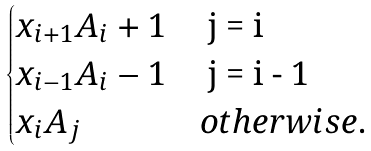<formula> <loc_0><loc_0><loc_500><loc_500>\begin{cases} x _ { i + 1 } A _ { i } + 1 & $ j = i $ \\ x _ { i - 1 } A _ { i } - 1 & $ j = i - 1 $ \\ x _ { i } A _ { j } & o t h e r w i s e . \end{cases}</formula> 